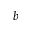<formula> <loc_0><loc_0><loc_500><loc_500>b</formula> 